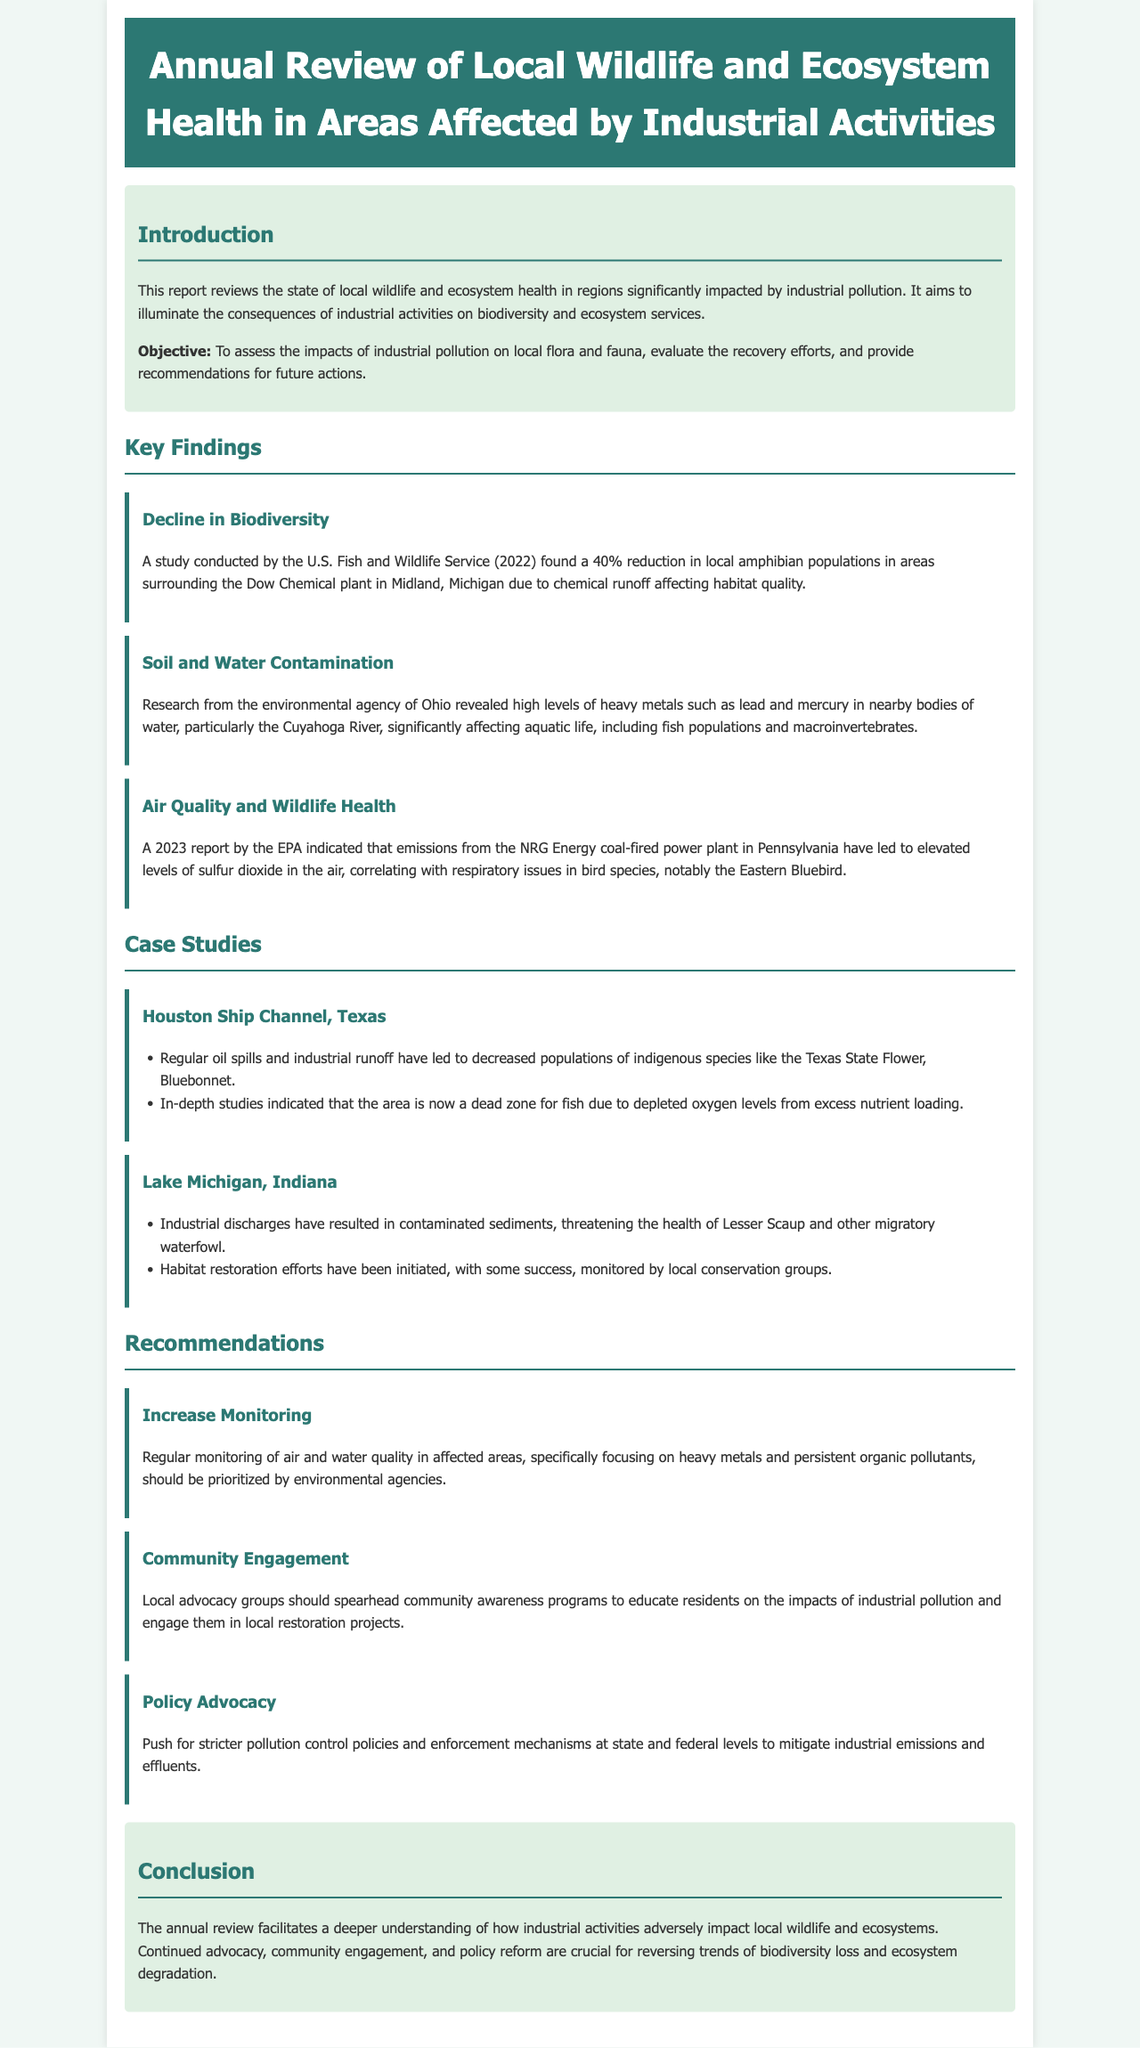What is the primary objective of the report? The objective of the report is to assess the impacts of industrial pollution on local flora and fauna, evaluate the recovery efforts, and provide recommendations for future actions.
Answer: To assess the impacts of industrial pollution on local flora and fauna What percentage of reduction was found in amphibian populations? The report states that a 40% reduction was found in local amphibian populations in areas surrounding the Dow Chemical plant.
Answer: 40% Which species experienced respiratory issues due to air quality? The report indicates that the Eastern Bluebird experienced respiratory issues related to emissions from the NRG Energy coal-fired power plant.
Answer: Eastern Bluebird What chemical contaminants were found in the Cuyahoga River? The environmental agency of Ohio revealed high levels of heavy metals, specifically lead and mercury, in the Cuyahoga River.
Answer: Lead and mercury Which location was identified as a dead zone for fish? The Houston Ship Channel was identified as a dead zone for fish due to depleted oxygen levels from excess nutrient loading.
Answer: Houston Ship Channel What type of engagement is recommended for local advocacy groups? The report recommends that local advocacy groups should spearhead community awareness programs.
Answer: Community awareness programs What is one of the key findings regarding soil and water? Research revealed high levels of heavy metals in nearby bodies of water affecting aquatic life.
Answer: High levels of heavy metals What is suggested for monitoring in affected areas? The report suggests that regular monitoring of air and water quality should be prioritized by environmental agencies.
Answer: Regular monitoring of air and water quality 